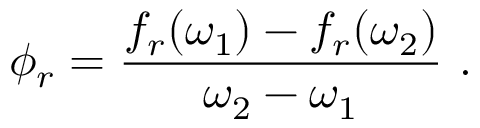<formula> <loc_0><loc_0><loc_500><loc_500>\phi _ { r } = \frac { f _ { r } ( \omega _ { 1 } ) - f _ { r } ( \omega _ { 2 } ) } { \omega _ { 2 } - \omega _ { 1 } } .</formula> 